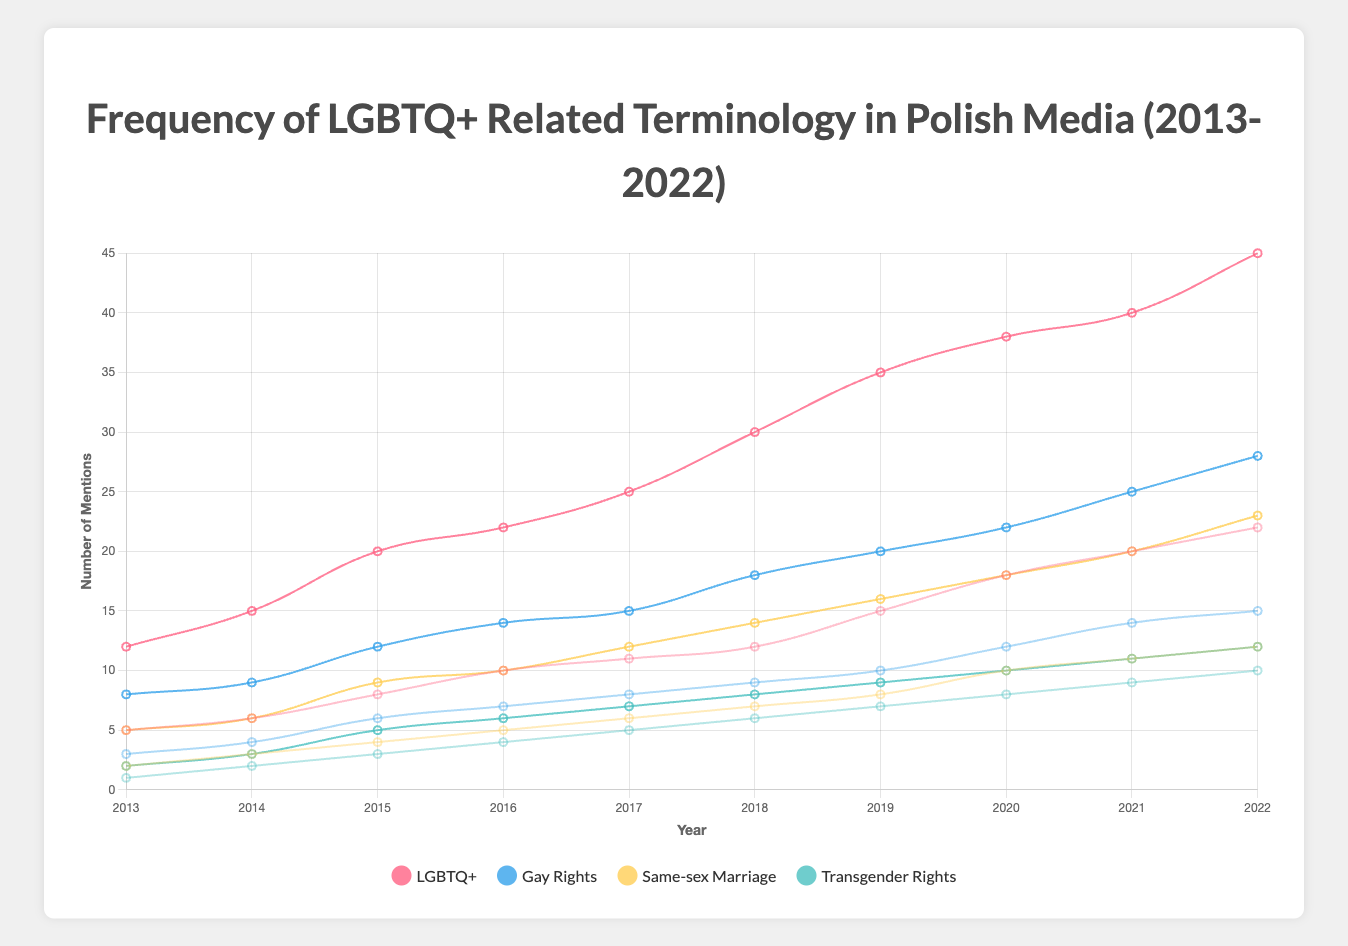What is the total number of mentions for "LGBTQ+" in the years 2016 and 2021 in Gazeta Wyborcza? First, find the mentions of "LGBTQ+" in Gazeta Wyborcza for both years: 22 in 2016 and 40 in 2021. Add these values: 22 + 40 = 62.
Answer: 62 Which newspaper had more mentions of "transgender rights" in 2020, and by how much? Compare the mentions of "transgender rights" in 2020: Gazeta Wyborcza had 10 and Rzeczpospolita had 8. Subtract the smaller number from the larger: 10 - 8 = 2.
Answer: Gazeta Wyborcza, by 2 Between 2018 and 2022, which terminology saw the highest overall increase in mentions in Gazeta Wyborcza? Determine the mentions for each term in 2018 and 2022, then subtract 2018 values from 2022 values:
- LGBTQ+: 45 - 30 = 15
- Gay rights: 28 - 18 = 10
- Same-sex marriage: 23 - 14 = 9
- Transgender rights: 12 - 8 = 4
The highest increase is for "LGBTQ+" with 15.
Answer: LGBTQ+ In what year did "gay rights" in Rzeczpospolita surpass 10 mentions, and what was the exact number of mentions? Look through the data for "gay rights" in Rzeczpospolita and find the first year with mentions exceeding 10. In 2020, "gay rights" had 12 mentions, which is the first year it surpassed 10.
Answer: 2020, 12 Compare the trend for "same-sex marriage" mentions in Gazeta Wyborcza to "same-sex marriage" mentions in Rzeczpospolita from 2013 to 2022. Analyze the visual lines representing "same-sex marriage" for both newspapers: 
- In Gazeta Wyborcza, the trend steadily increases from 5 in 2013 to 23 in 2022.
- In Rzeczpospolita, it also increases but at a slower pace, from 2 in 2013 to 12 in 2022. 
Gazeta Wyborcza saw a steeper increase compared to Rzeczpospolita.
Answer: Gazeta Wyborcza saw a steeper increase How many total mentions do "transgender rights" have across all sources in 2019? Sum the mentions of "transgender rights" for both sources in 2019: Gazeta Wyborcza had 9 and Rzeczpospolita had 7. The total is 9 + 7 = 16.
Answer: 16 Between 2013 and 2015, which year saw the highest mentions of "gay rights" in Rzeczpospolita, and what were the mentions? Examine the data for "gay rights" in Rzeczpospolita from 2013 to 2015:
- 2013: 3 mentions
- 2014: 4 mentions
- 2015: 6 mentions
The highest is in 2015 with 6 mentions.
Answer: 2015, 6 Which year shows the largest gap in "LGBTQ+" mentions between Gazeta Wyborcza and Rzeczpospolita, and what is the gap? Calculate the gap for each year, but focus on the gap's maximum value:
- 2013: 12 - 5 = 7
- 2014: 15 - 6 = 9
- 2015: 20 - 8 = 12
- 2016: 22 - 10 = 12
- 2017: 25 - 11 = 14
- 2018: 30 - 12 = 18
- 2019: 35 - 15 = 20
- 2020: 38 - 18 = 20
- 2021: 40 - 20 = 20
- 2022: 45 - 22 = 23
The largest gap is in 2022 with a gap of 23.
Answer: 2022, 23 